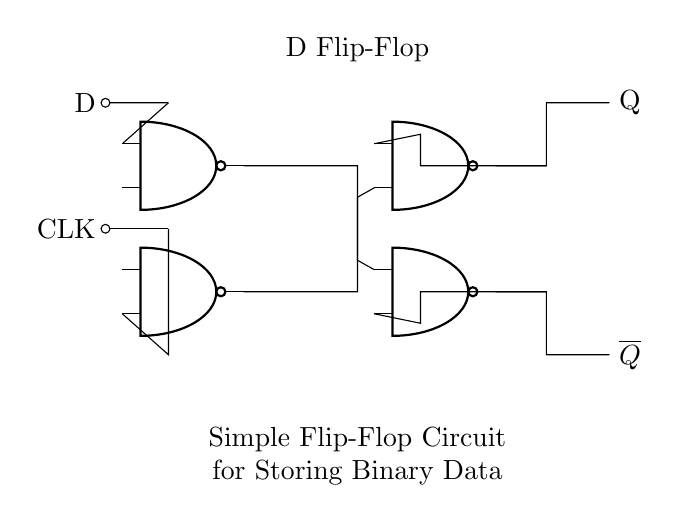What components are used in this circuit? The main components are NAND gates, a clock input, and a data input (D). These components are interconnected to form the flip-flop circuit.
Answer: NAND gates, clock input, D input What is the output designation for this flip-flop? The output from the flip-flop is represented as Q and its complement is represented as Q bar (overline Q). These outputs store the binary data.
Answer: Q and Q bar How many NAND gates are in the circuit? There are four NAND gates used in this flip-flop circuit. The diagram indicates these components clearly and allows counting them.
Answer: Four What happens to Q when D is high on the clock's rising edge? When D is high on the clock's rising edge, Q will also go high (1) because the flip-flop is designed to capture the D input at this moment.
Answer: Q becomes high What is the role of the feedback loops in this flip-flop circuit? The feedback loops connect the outputs back to the inputs of the NAND gates, allowing the circuit to store the previous state and maintain stability when the clock is not triggering a change.
Answer: To store the previous state Which component controls when the data (D) is sampled? The clock (CLK) input controls when the data is sampled by enabling the flip-flop to capture the input value on the rising edge of the clock signal.
Answer: Clock input What is the significance of having Q and Q bar outputs? Q and Q bar provide complementary outputs; this configuration allows the flip-flop to represent a binary state (0 or 1) and is essential for various digital applications such as memory storage.
Answer: Represents complementary binary states 